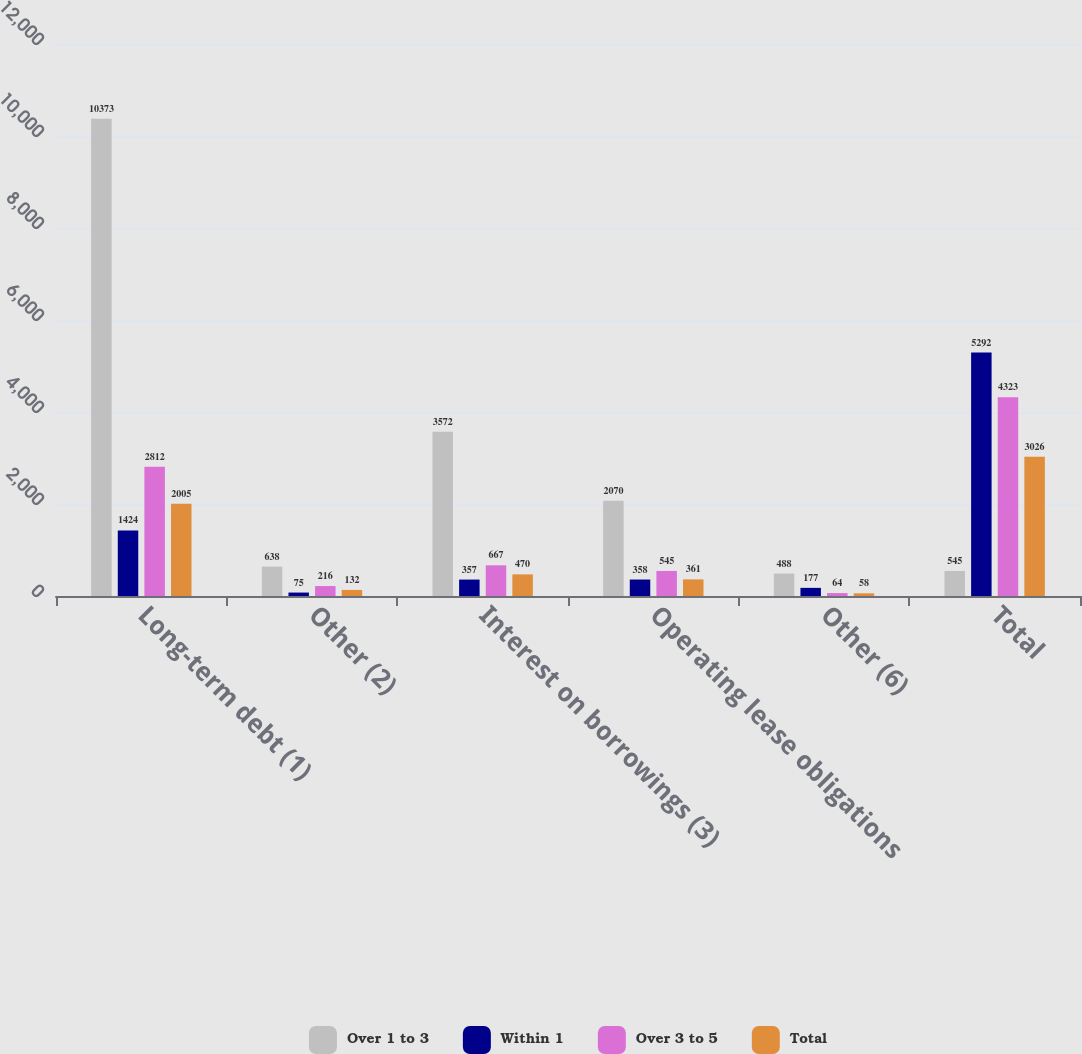Convert chart to OTSL. <chart><loc_0><loc_0><loc_500><loc_500><stacked_bar_chart><ecel><fcel>Long-term debt (1)<fcel>Other (2)<fcel>Interest on borrowings (3)<fcel>Operating lease obligations<fcel>Other (6)<fcel>Total<nl><fcel>Over 1 to 3<fcel>10373<fcel>638<fcel>3572<fcel>2070<fcel>488<fcel>545<nl><fcel>Within 1<fcel>1424<fcel>75<fcel>357<fcel>358<fcel>177<fcel>5292<nl><fcel>Over 3 to 5<fcel>2812<fcel>216<fcel>667<fcel>545<fcel>64<fcel>4323<nl><fcel>Total<fcel>2005<fcel>132<fcel>470<fcel>361<fcel>58<fcel>3026<nl></chart> 